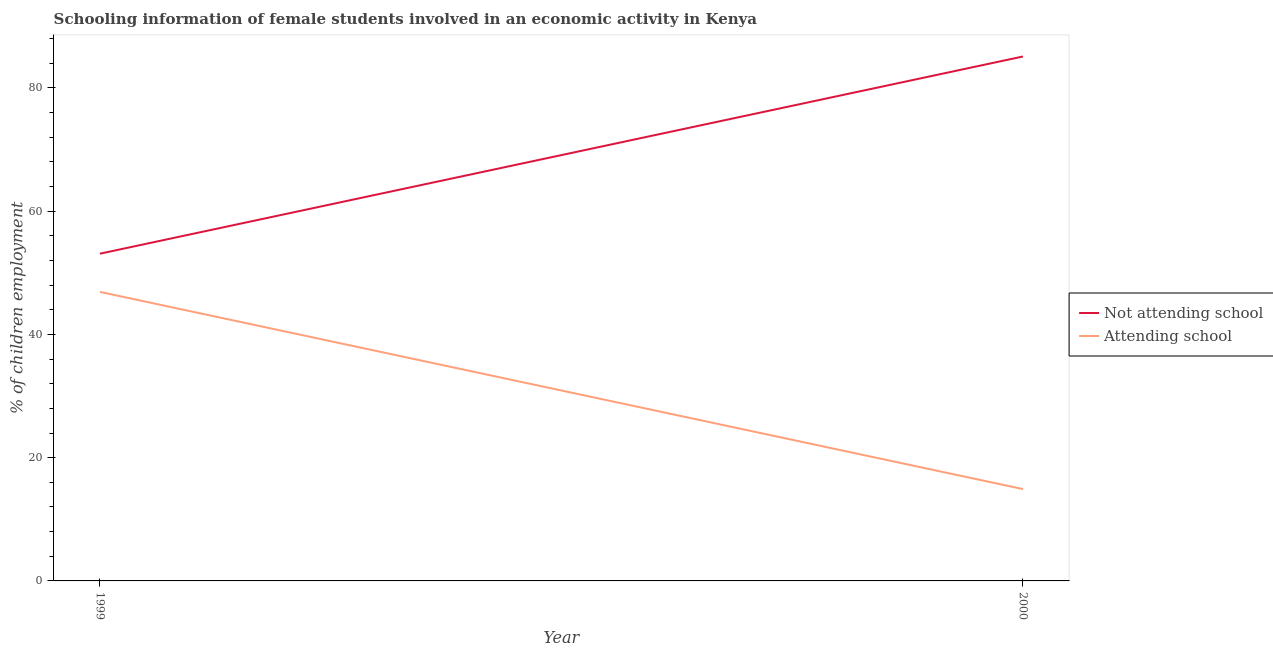How many different coloured lines are there?
Provide a succinct answer. 2. Does the line corresponding to percentage of employed females who are attending school intersect with the line corresponding to percentage of employed females who are not attending school?
Provide a short and direct response. No. What is the percentage of employed females who are attending school in 1999?
Make the answer very short. 46.9. Across all years, what is the maximum percentage of employed females who are attending school?
Ensure brevity in your answer.  46.9. What is the total percentage of employed females who are not attending school in the graph?
Keep it short and to the point. 138.2. What is the difference between the percentage of employed females who are not attending school in 1999 and that in 2000?
Your answer should be very brief. -32. What is the difference between the percentage of employed females who are attending school in 2000 and the percentage of employed females who are not attending school in 1999?
Ensure brevity in your answer.  -38.2. What is the average percentage of employed females who are attending school per year?
Offer a very short reply. 30.9. In the year 1999, what is the difference between the percentage of employed females who are attending school and percentage of employed females who are not attending school?
Keep it short and to the point. -6.2. What is the ratio of the percentage of employed females who are attending school in 1999 to that in 2000?
Give a very brief answer. 3.15. Is the percentage of employed females who are attending school strictly greater than the percentage of employed females who are not attending school over the years?
Your response must be concise. No. What is the difference between two consecutive major ticks on the Y-axis?
Offer a very short reply. 20. Does the graph contain grids?
Provide a succinct answer. No. Where does the legend appear in the graph?
Ensure brevity in your answer.  Center right. What is the title of the graph?
Your answer should be very brief. Schooling information of female students involved in an economic activity in Kenya. What is the label or title of the Y-axis?
Make the answer very short. % of children employment. What is the % of children employment in Not attending school in 1999?
Your answer should be compact. 53.1. What is the % of children employment in Attending school in 1999?
Provide a short and direct response. 46.9. What is the % of children employment of Not attending school in 2000?
Your answer should be very brief. 85.1. What is the % of children employment of Attending school in 2000?
Give a very brief answer. 14.9. Across all years, what is the maximum % of children employment in Not attending school?
Offer a very short reply. 85.1. Across all years, what is the maximum % of children employment of Attending school?
Offer a terse response. 46.9. Across all years, what is the minimum % of children employment of Not attending school?
Offer a very short reply. 53.1. Across all years, what is the minimum % of children employment of Attending school?
Provide a short and direct response. 14.9. What is the total % of children employment of Not attending school in the graph?
Ensure brevity in your answer.  138.2. What is the total % of children employment in Attending school in the graph?
Make the answer very short. 61.8. What is the difference between the % of children employment in Not attending school in 1999 and that in 2000?
Make the answer very short. -32. What is the difference between the % of children employment of Not attending school in 1999 and the % of children employment of Attending school in 2000?
Ensure brevity in your answer.  38.2. What is the average % of children employment of Not attending school per year?
Make the answer very short. 69.1. What is the average % of children employment of Attending school per year?
Ensure brevity in your answer.  30.9. In the year 1999, what is the difference between the % of children employment of Not attending school and % of children employment of Attending school?
Provide a short and direct response. 6.2. In the year 2000, what is the difference between the % of children employment of Not attending school and % of children employment of Attending school?
Your answer should be compact. 70.2. What is the ratio of the % of children employment in Not attending school in 1999 to that in 2000?
Your answer should be very brief. 0.62. What is the ratio of the % of children employment in Attending school in 1999 to that in 2000?
Offer a very short reply. 3.15. What is the difference between the highest and the lowest % of children employment of Attending school?
Keep it short and to the point. 32. 